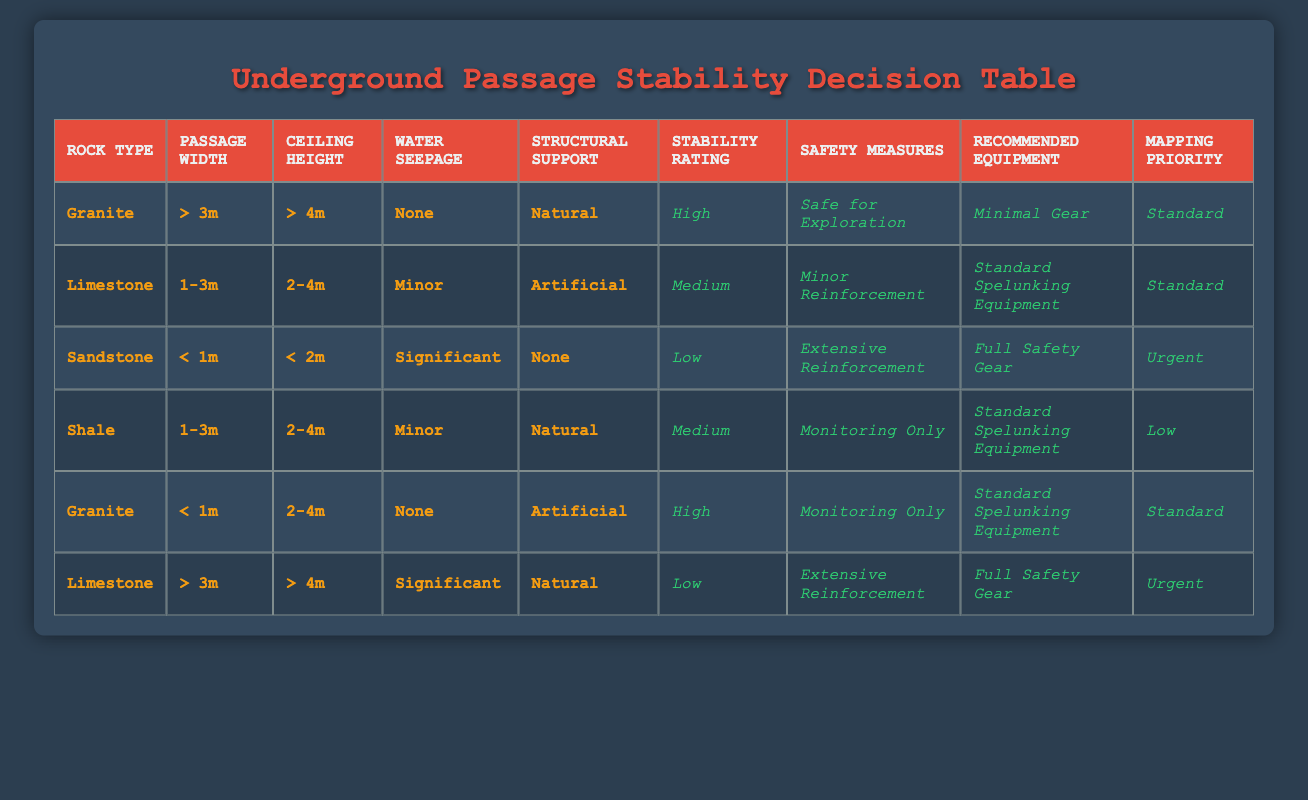What is the stability rating for passages with Granite rock type that have more than 3m width and more than 4m ceiling height? According to the table, for Granite with the specified dimensions, the stability rating is listed as High in the relevant row.
Answer: High Which passage type requires full safety gear? The table indicates that Sandstone passages with a width of less than 1m, a ceiling height of less than 2m, and significant water seepage require Full Safety Gear as stated in that row.
Answer: Sandstone What are the recommended safety measures for Limestone passages with a width of 1-3m, a ceiling height of 2-4m, minor water seepage, and artificial support? From the table, this combination of conditions matches the row where Limestone is classified as having Medium stability, leading to Minor Reinforcement as the recommended safety measure.
Answer: Minor Reinforcement How many types of rock lead to a stability rating of Low? In the table, only one specific type, Sandstone, shows a stability rating of Low. Therefore, only Sandstone qualifies under the given conditions.
Answer: 1 Is there any combination listed where Granite has a stability rating of Low? The table clearly shows that all combinations involving Granite have either High stability, and there are no entries for Low stability under Granite. Thus, it’s confirmed there are no such combinations.
Answer: No Which rock type has the highest stability rating and what is the corresponding mapping priority? The highest stability rating is High, found under both conditions for Granite passages (one with width > 3m and ceiling height > 4m, the other with width < 1m and ceiling height 2-4m), both of which have a mapping priority of Standard. However, because of commonality in the table, the priority is Standard.
Answer: Standard What is the average ceiling height for passages classified as having a Medium stability rating? Here, we observe that both Limestone and Shale correspond to Medium stability. The ceiling height for Limestone is between 2-4m (we can take an average of 3m), and for Shale, it also falls in the 2-4m range (similarly, the average is 3m). Thus, the average ceiling height for Medium stability would be around 3m.
Answer: 3m For a safe exploration recommendation, what types of rock are involved? Noting from the table, the only combinations where the safety recommendation is Safe for Exploration are both for Granite types — one with conditions of width > 3m, height > 4m and the other width < 1m with height 2-4m.
Answer: Granite What is the stability rating for a Limestone passage with a width greater than 3m, a ceiling height greater than 4m, and significant water seepage? By inspecting the table, it shows that this specific combination corresponds to a stability rating of Low as outlined in the Limestone row.
Answer: Low 